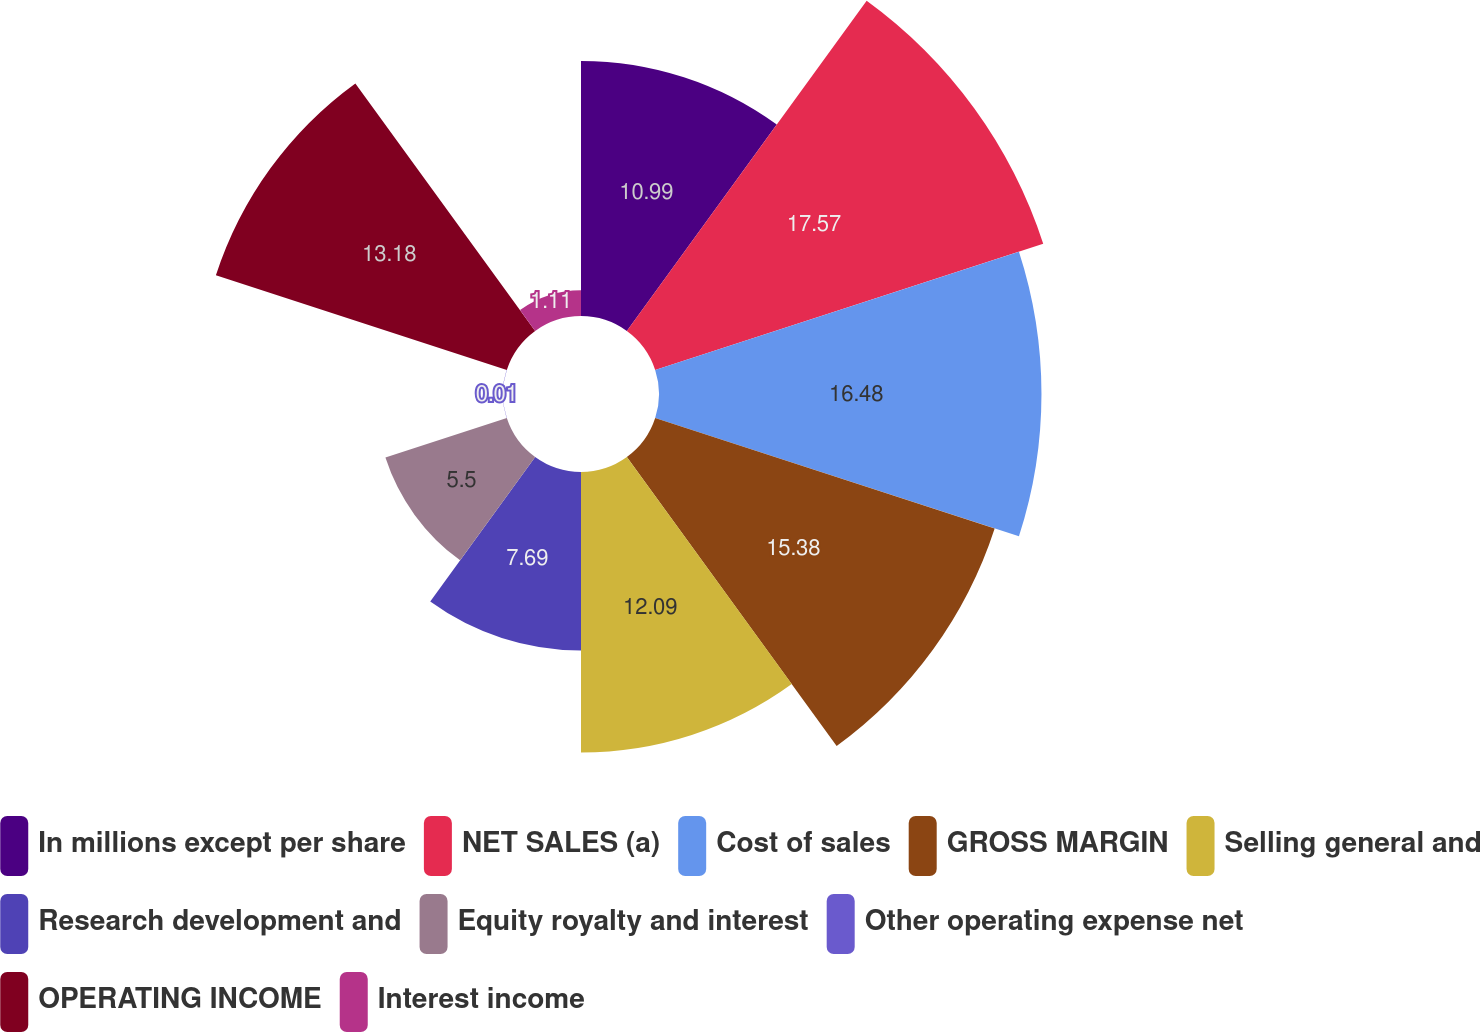Convert chart. <chart><loc_0><loc_0><loc_500><loc_500><pie_chart><fcel>In millions except per share<fcel>NET SALES (a)<fcel>Cost of sales<fcel>GROSS MARGIN<fcel>Selling general and<fcel>Research development and<fcel>Equity royalty and interest<fcel>Other operating expense net<fcel>OPERATING INCOME<fcel>Interest income<nl><fcel>10.99%<fcel>17.58%<fcel>16.48%<fcel>15.38%<fcel>12.09%<fcel>7.69%<fcel>5.5%<fcel>0.01%<fcel>13.18%<fcel>1.11%<nl></chart> 